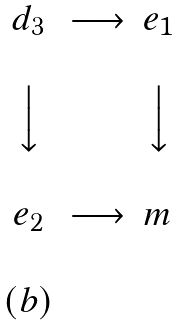<formula> <loc_0><loc_0><loc_500><loc_500>\begin{matrix} & & & \\ & d _ { 3 } & \longrightarrow & e _ { 1 } \\ & & & \\ & \Big \downarrow & & \Big \downarrow \\ & & & \\ & e _ { 2 } & \longrightarrow & m \\ & & & \\ & ( b ) & & \\ \end{matrix}</formula> 